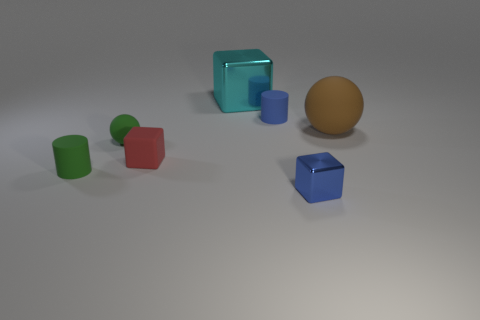What material is the red thing that is the same shape as the cyan metallic object?
Ensure brevity in your answer.  Rubber. Is the material of the small red thing the same as the tiny blue thing that is in front of the small rubber ball?
Your response must be concise. No. There is a tiny blue thing that is in front of the rubber ball that is in front of the large brown sphere; what is its shape?
Your response must be concise. Cube. What number of tiny objects are rubber objects or rubber blocks?
Keep it short and to the point. 4. How many red rubber objects have the same shape as the cyan metal thing?
Your response must be concise. 1. There is a cyan shiny thing; does it have the same shape as the red rubber object left of the blue metallic thing?
Offer a very short reply. Yes. How many green balls are on the right side of the big cube?
Provide a succinct answer. 0. Is there a matte ball that has the same size as the blue metallic thing?
Make the answer very short. Yes. There is a small thing right of the small blue rubber thing; is its shape the same as the cyan shiny object?
Provide a succinct answer. Yes. What is the color of the small sphere?
Offer a terse response. Green. 